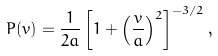Convert formula to latex. <formula><loc_0><loc_0><loc_500><loc_500>P ( v ) = \frac { 1 } { 2 a } \left [ 1 + \left ( \frac { v } { a } \right ) ^ { 2 } \right ] ^ { - 3 / 2 } ,</formula> 